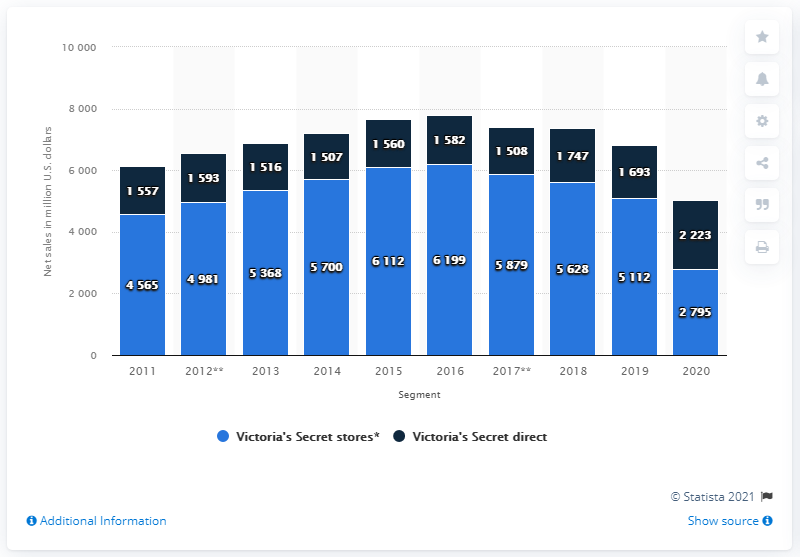Identify some key points in this picture. In 2016, the tallest bar occurred. The total value of the 2020s bar is 5018. 